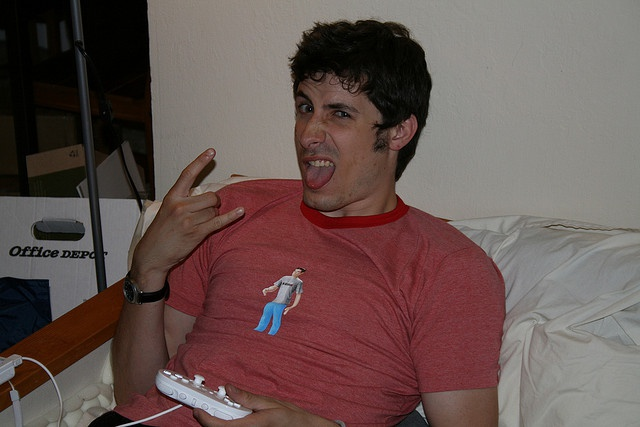Describe the objects in this image and their specific colors. I can see people in black, maroon, and brown tones, couch in black, gray, and maroon tones, and remote in black, darkgray, gray, and lightgray tones in this image. 